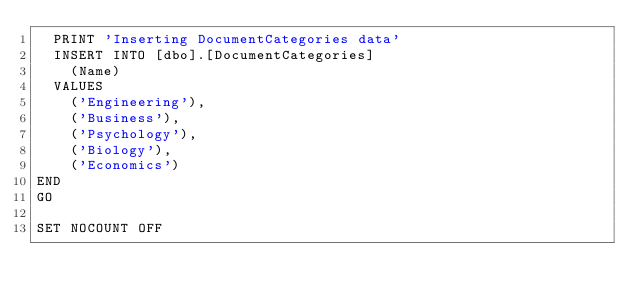<code> <loc_0><loc_0><loc_500><loc_500><_SQL_>	PRINT 'Inserting DocumentCategories data'
	INSERT INTO [dbo].[DocumentCategories] 
		(Name)
	VALUES
		('Engineering'),
		('Business'),
		('Psychology'),
		('Biology'),
		('Economics')
END
GO

SET NOCOUNT OFF</code> 